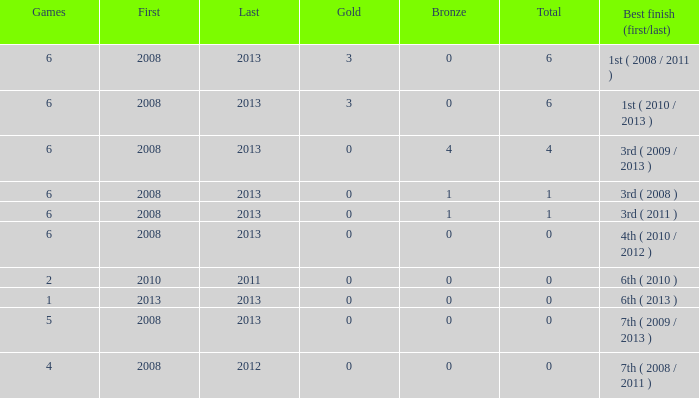How many bronzes associated with over 0 total medals, 3 golds, and over 6 games? None. 